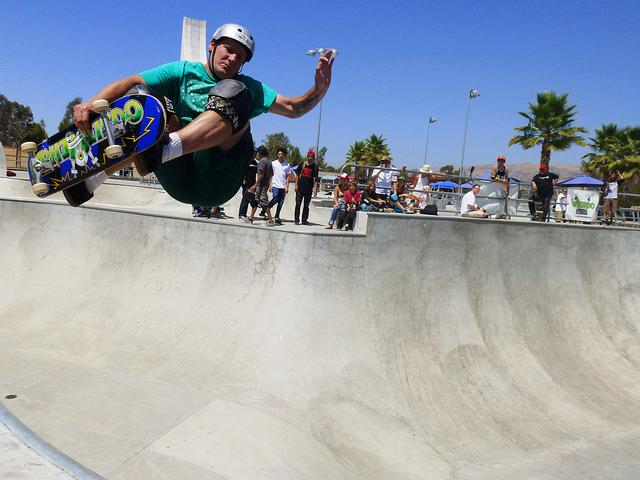What is this skateboarding feature?

Choices:
A) funbox
B) bowl
C) rail
D) half-pipe half-pipe 